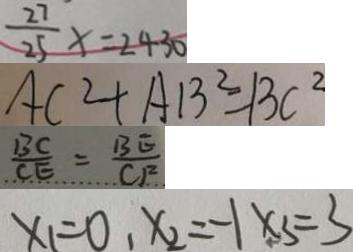<formula> <loc_0><loc_0><loc_500><loc_500>\frac { 2 7 } { 2 5 } x = 2 4 3 0 
 A C ^ { 2 } + A B ^ { 2 } = B C ^ { 2 } 
 \frac { B C } { C E } = \frac { B E } { C F } 
 x _ { 1 } = 0 , x _ { 2 } = - 1 x _ { 3 } = 3</formula> 